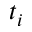<formula> <loc_0><loc_0><loc_500><loc_500>t _ { i }</formula> 